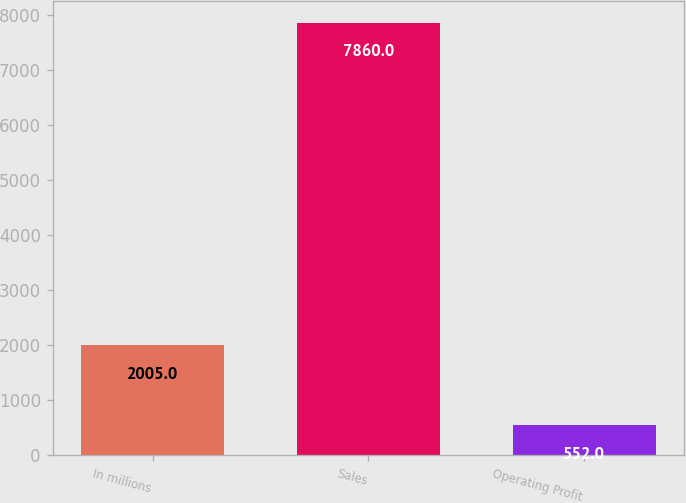Convert chart to OTSL. <chart><loc_0><loc_0><loc_500><loc_500><bar_chart><fcel>In millions<fcel>Sales<fcel>Operating Profit<nl><fcel>2005<fcel>7860<fcel>552<nl></chart> 